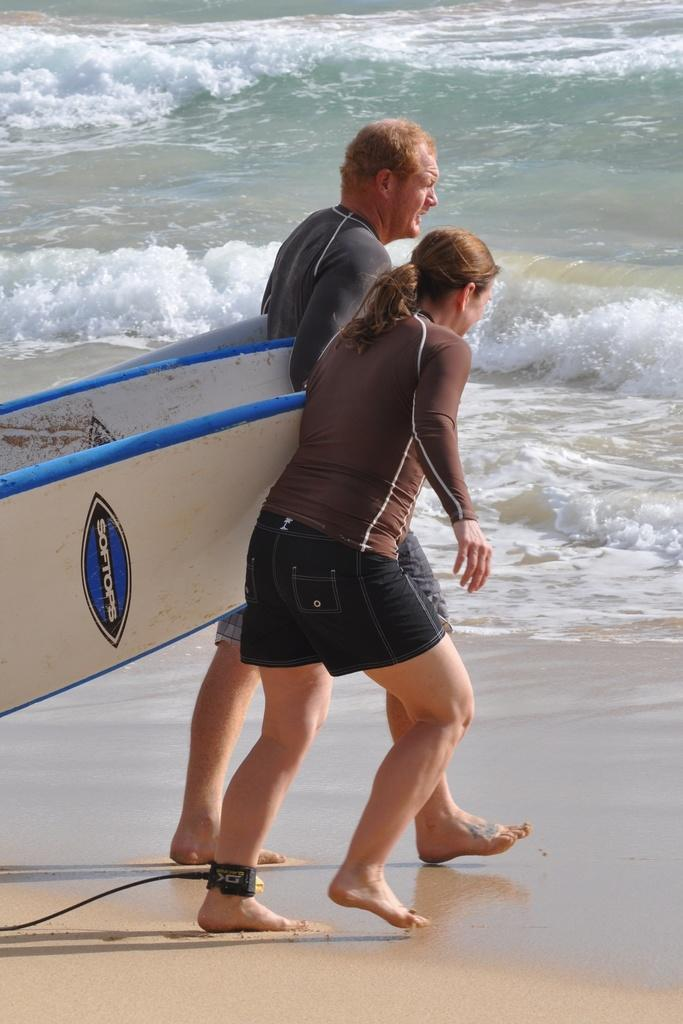Who is present in the image? There is a man and a woman in the image. What are the man and woman doing in the image? Both the man and woman are walking into the water. What objects are the man and woman holding in their hands? The man and woman are holding surfboards in their hands. Can you see the aunt of the man in the image? There is no mention of an aunt in the image, so it cannot be determined if she is present. What type of dinosaurs can be seen in the image? There are no dinosaurs present in the image. 